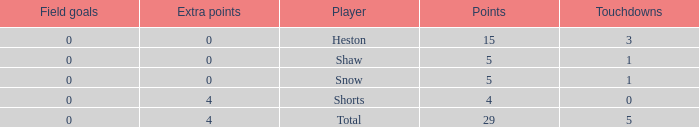What is the total number of field goals for a player that had less than 3 touchdowns, had 4 points, and had less than 4 extra points? 0.0. 